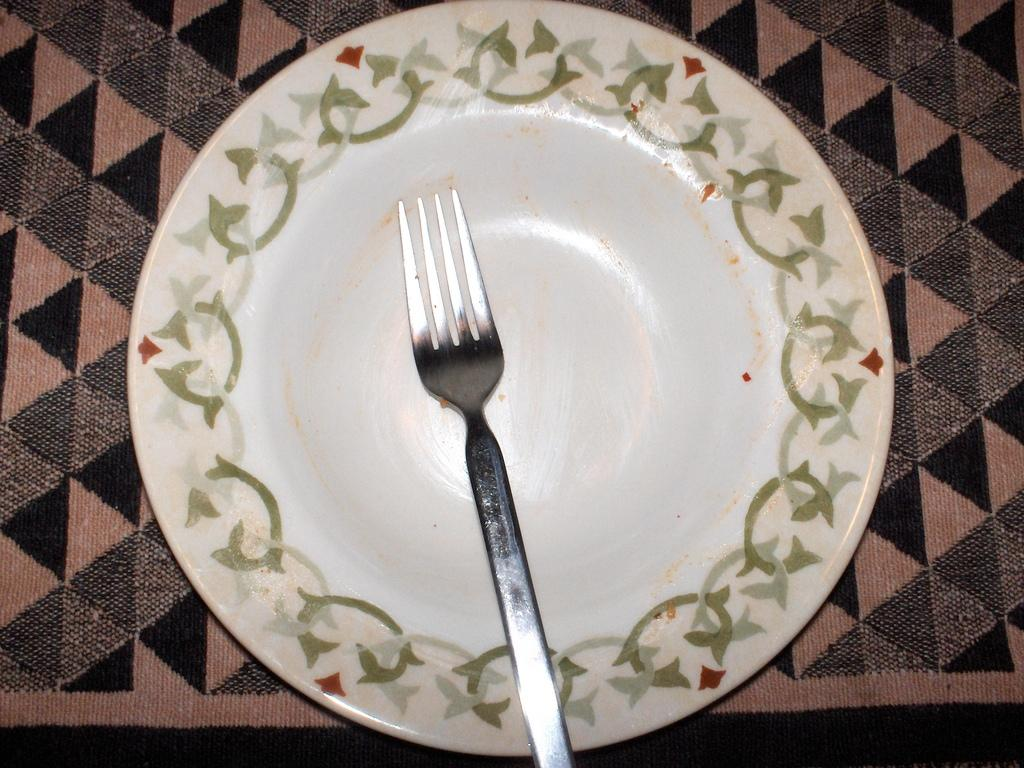What utensil is visible in the image? There is a fork in the image. Where is the fork located? The fork is on a plate. What is the plate placed on? The plate is placed on a surface. What story is the baby telling in the image? There is no baby present in the image, so no story can be told. 